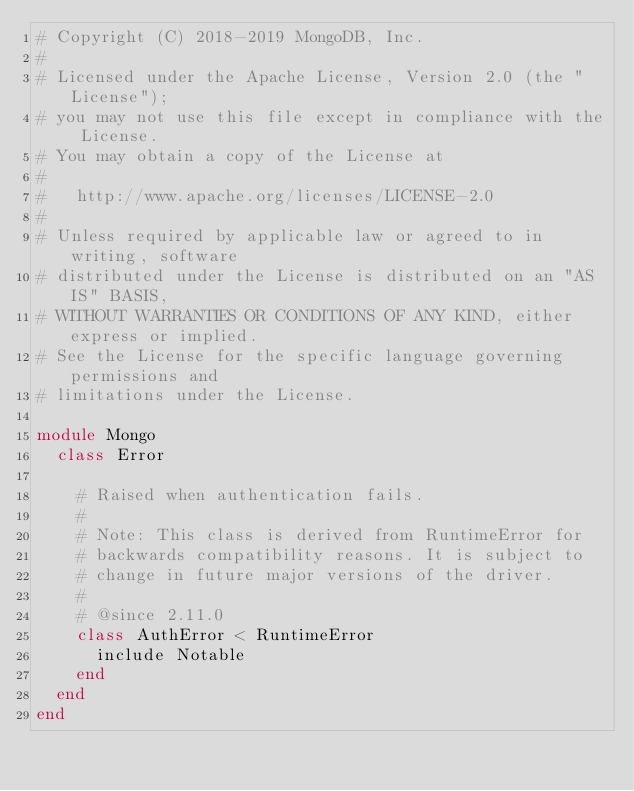Convert code to text. <code><loc_0><loc_0><loc_500><loc_500><_Ruby_># Copyright (C) 2018-2019 MongoDB, Inc.
#
# Licensed under the Apache License, Version 2.0 (the "License");
# you may not use this file except in compliance with the License.
# You may obtain a copy of the License at
#
#   http://www.apache.org/licenses/LICENSE-2.0
#
# Unless required by applicable law or agreed to in writing, software
# distributed under the License is distributed on an "AS IS" BASIS,
# WITHOUT WARRANTIES OR CONDITIONS OF ANY KIND, either express or implied.
# See the License for the specific language governing permissions and
# limitations under the License.

module Mongo
  class Error

    # Raised when authentication fails.
    #
    # Note: This class is derived from RuntimeError for
    # backwards compatibility reasons. It is subject to
    # change in future major versions of the driver.
    #
    # @since 2.11.0
    class AuthError < RuntimeError
      include Notable
    end
  end
end
</code> 